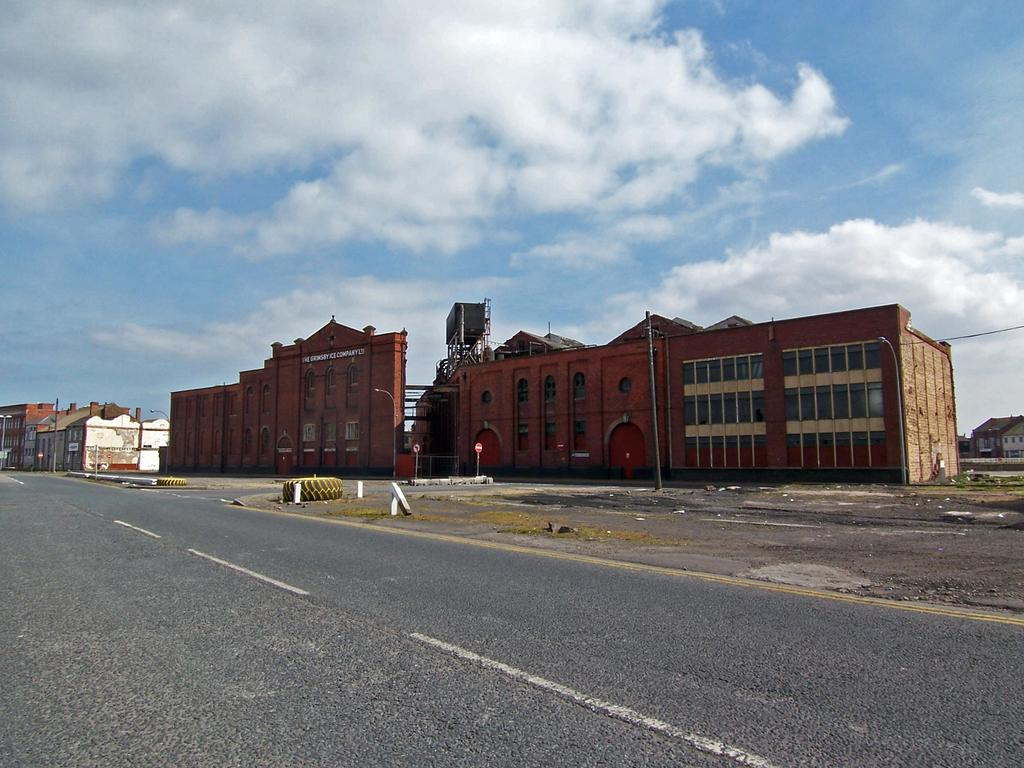What is the main feature of the image? There is a road in the image. What objects are related to the road? There are tyres, poles, boards, and a light in the image. Are there any structures visible in the image? Yes, there are buildings in the image. What can be seen in the background of the image? The sky is visible in the background of the image, and clouds are present in the sky. What type of bone can be seen in the image? There is no bone present in the image. How does the motion of the push affect the objects in the image? There is no motion or push present in the image; it is a still image. 